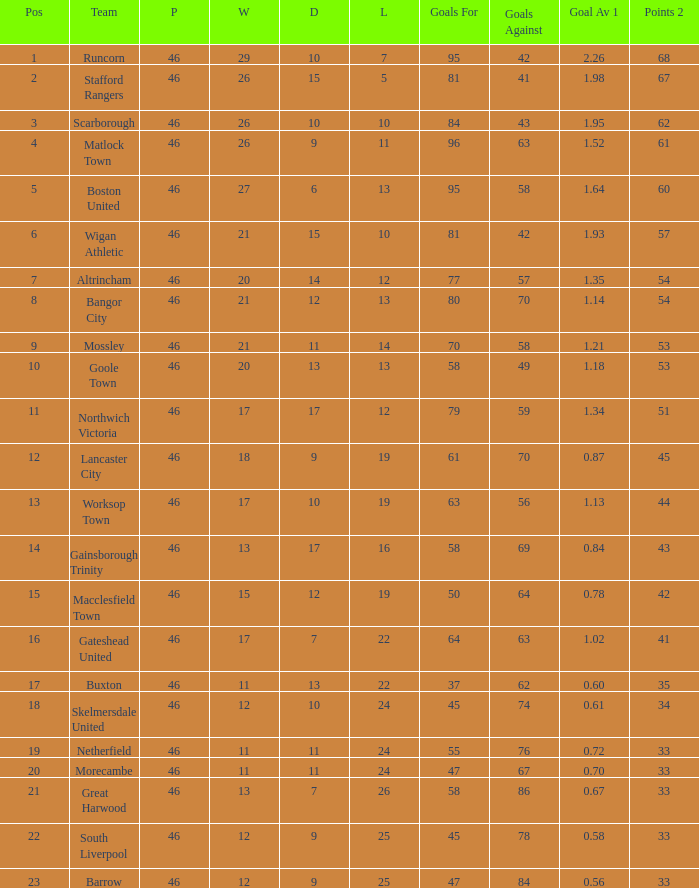Which team possessed goal averages of Northwich Victoria. 